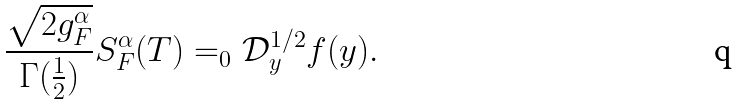Convert formula to latex. <formula><loc_0><loc_0><loc_500><loc_500>\frac { \sqrt { 2 g _ { F } ^ { \alpha } } } { \Gamma ( \frac { 1 } { 2 } ) } S _ { F } ^ { \alpha } ( T ) = _ { 0 } \mathcal { D } _ { y } ^ { 1 / 2 } f ( y ) .</formula> 